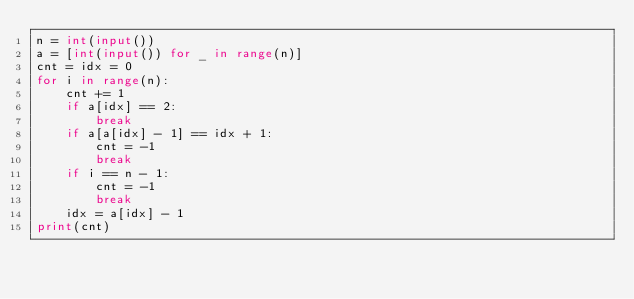<code> <loc_0><loc_0><loc_500><loc_500><_Python_>n = int(input())
a = [int(input()) for _ in range(n)]
cnt = idx = 0
for i in range(n):
    cnt += 1
    if a[idx] == 2:
        break
    if a[a[idx] - 1] == idx + 1:
        cnt = -1
        break
    if i == n - 1:
        cnt = -1
        break
    idx = a[idx] - 1
print(cnt)</code> 